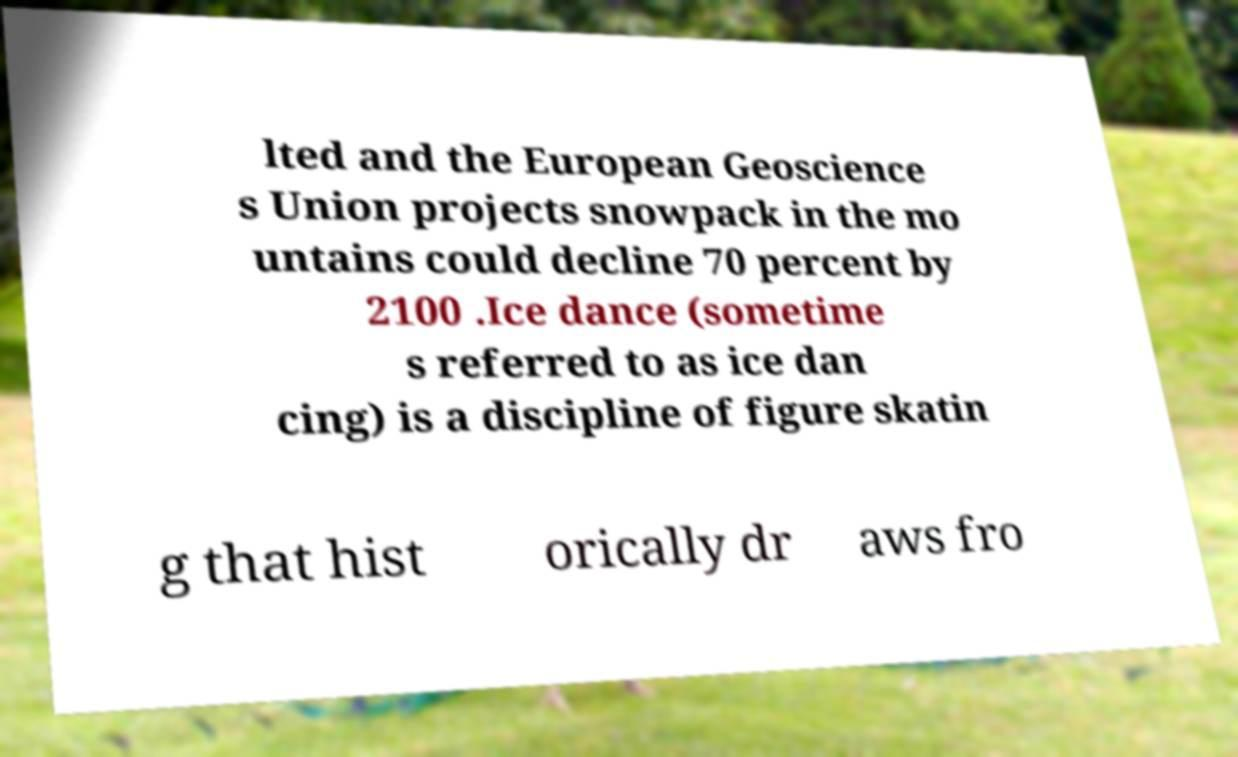Could you extract and type out the text from this image? lted and the European Geoscience s Union projects snowpack in the mo untains could decline 70 percent by 2100 .Ice dance (sometime s referred to as ice dan cing) is a discipline of figure skatin g that hist orically dr aws fro 